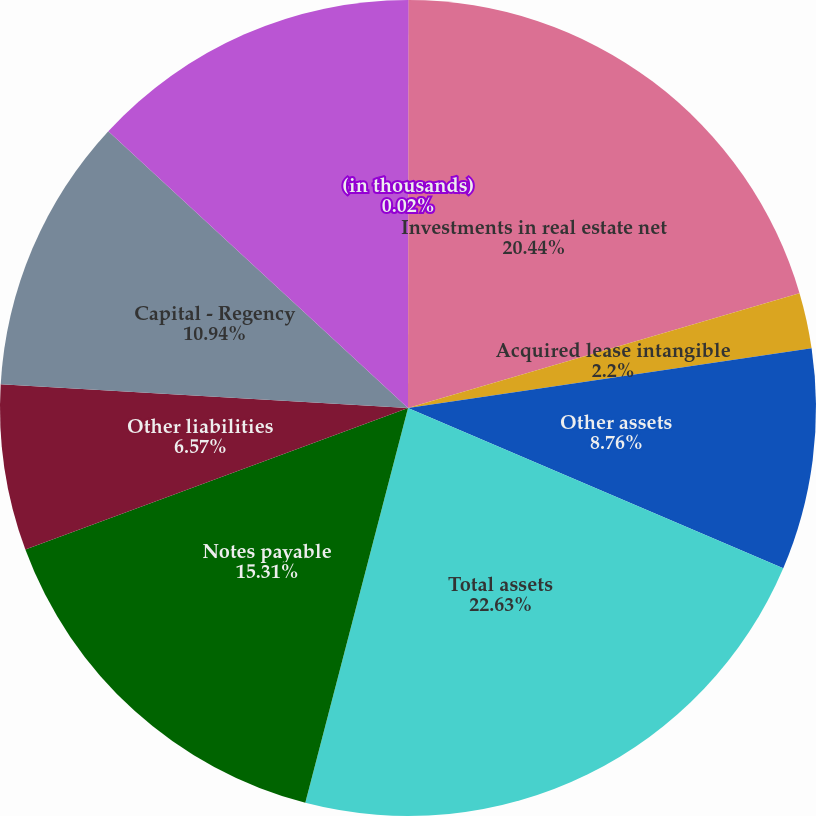Convert chart. <chart><loc_0><loc_0><loc_500><loc_500><pie_chart><fcel>(in thousands)<fcel>Investments in real estate net<fcel>Acquired lease intangible<fcel>Other assets<fcel>Total assets<fcel>Notes payable<fcel>Other liabilities<fcel>Capital - Regency<fcel>Capital - Third parties<nl><fcel>0.02%<fcel>20.44%<fcel>2.2%<fcel>8.76%<fcel>22.63%<fcel>15.31%<fcel>6.57%<fcel>10.94%<fcel>13.13%<nl></chart> 